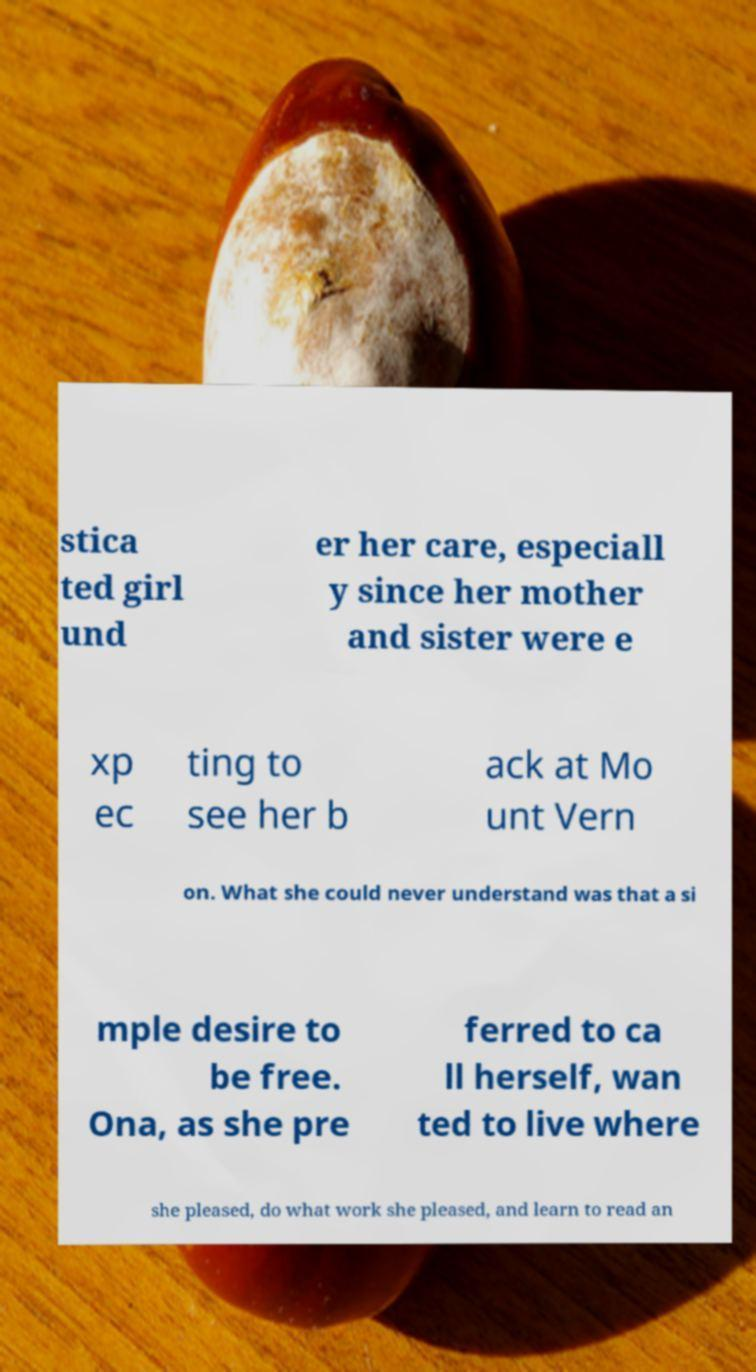Can you read and provide the text displayed in the image?This photo seems to have some interesting text. Can you extract and type it out for me? stica ted girl und er her care, especiall y since her mother and sister were e xp ec ting to see her b ack at Mo unt Vern on. What she could never understand was that a si mple desire to be free. Ona, as she pre ferred to ca ll herself, wan ted to live where she pleased, do what work she pleased, and learn to read an 